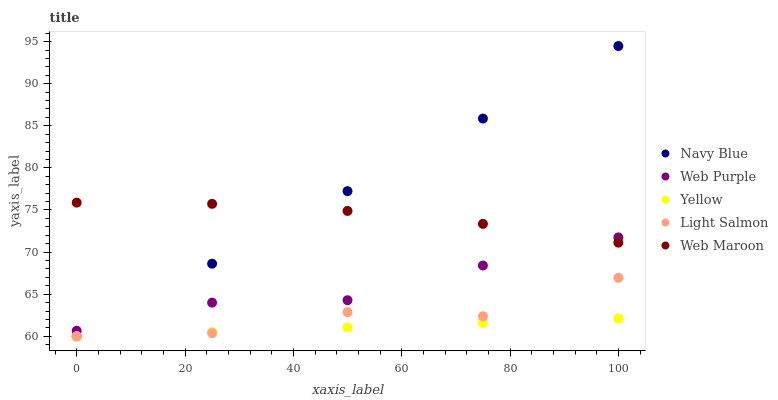Does Yellow have the minimum area under the curve?
Answer yes or no. Yes. Does Navy Blue have the maximum area under the curve?
Answer yes or no. Yes. Does Web Purple have the minimum area under the curve?
Answer yes or no. No. Does Web Purple have the maximum area under the curve?
Answer yes or no. No. Is Yellow the smoothest?
Answer yes or no. Yes. Is Light Salmon the roughest?
Answer yes or no. Yes. Is Web Purple the smoothest?
Answer yes or no. No. Is Web Purple the roughest?
Answer yes or no. No. Does Navy Blue have the lowest value?
Answer yes or no. Yes. Does Web Purple have the lowest value?
Answer yes or no. No. Does Navy Blue have the highest value?
Answer yes or no. Yes. Does Web Purple have the highest value?
Answer yes or no. No. Is Light Salmon less than Web Maroon?
Answer yes or no. Yes. Is Web Purple greater than Light Salmon?
Answer yes or no. Yes. Does Web Maroon intersect Navy Blue?
Answer yes or no. Yes. Is Web Maroon less than Navy Blue?
Answer yes or no. No. Is Web Maroon greater than Navy Blue?
Answer yes or no. No. Does Light Salmon intersect Web Maroon?
Answer yes or no. No. 